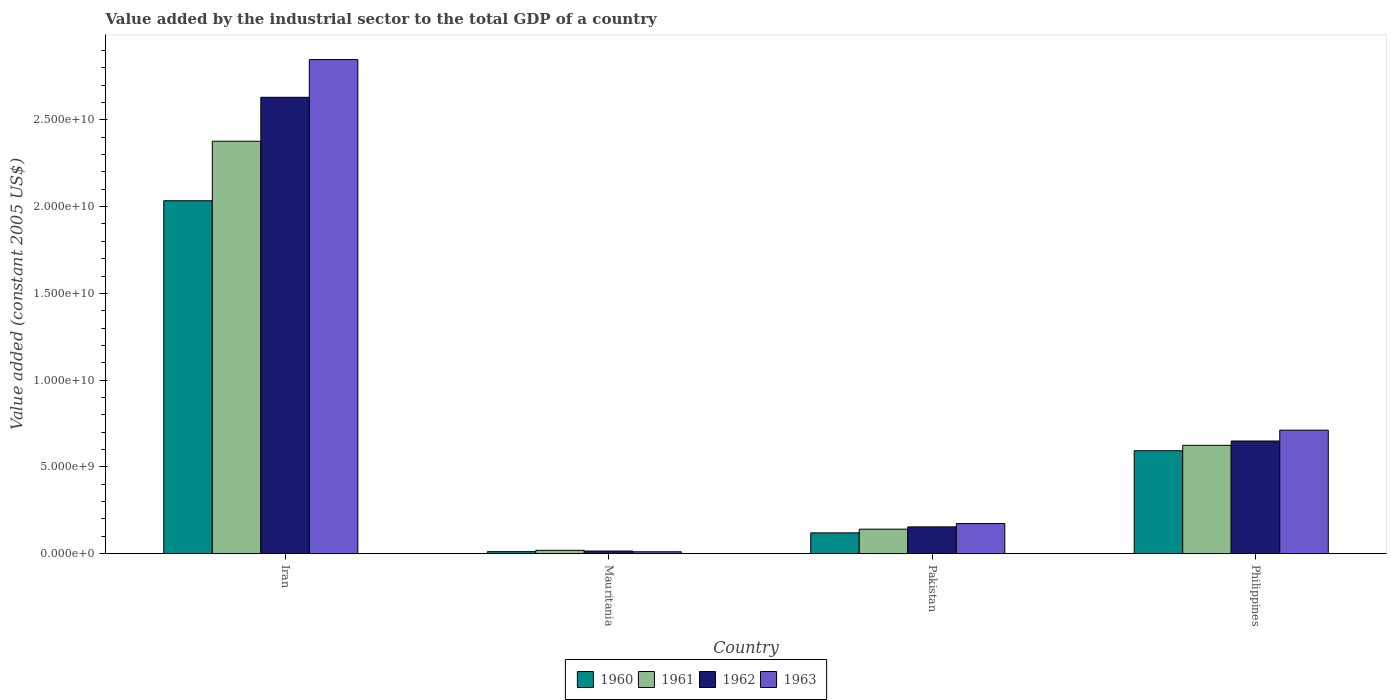How many different coloured bars are there?
Offer a very short reply. 4. Are the number of bars per tick equal to the number of legend labels?
Offer a terse response. Yes. How many bars are there on the 1st tick from the left?
Keep it short and to the point. 4. How many bars are there on the 1st tick from the right?
Make the answer very short. 4. In how many cases, is the number of bars for a given country not equal to the number of legend labels?
Offer a terse response. 0. What is the value added by the industrial sector in 1962 in Iran?
Ensure brevity in your answer.  2.63e+1. Across all countries, what is the maximum value added by the industrial sector in 1960?
Keep it short and to the point. 2.03e+1. Across all countries, what is the minimum value added by the industrial sector in 1962?
Your answer should be compact. 1.51e+08. In which country was the value added by the industrial sector in 1962 maximum?
Make the answer very short. Iran. In which country was the value added by the industrial sector in 1961 minimum?
Your answer should be compact. Mauritania. What is the total value added by the industrial sector in 1960 in the graph?
Ensure brevity in your answer.  2.76e+1. What is the difference between the value added by the industrial sector in 1960 in Mauritania and that in Philippines?
Your answer should be very brief. -5.82e+09. What is the difference between the value added by the industrial sector in 1963 in Mauritania and the value added by the industrial sector in 1960 in Philippines?
Provide a succinct answer. -5.82e+09. What is the average value added by the industrial sector in 1962 per country?
Your answer should be compact. 8.62e+09. What is the difference between the value added by the industrial sector of/in 1961 and value added by the industrial sector of/in 1962 in Pakistan?
Your answer should be compact. -1.32e+08. In how many countries, is the value added by the industrial sector in 1961 greater than 19000000000 US$?
Your answer should be compact. 1. What is the ratio of the value added by the industrial sector in 1961 in Iran to that in Philippines?
Offer a very short reply. 3.81. What is the difference between the highest and the second highest value added by the industrial sector in 1962?
Ensure brevity in your answer.  -1.98e+1. What is the difference between the highest and the lowest value added by the industrial sector in 1962?
Offer a very short reply. 2.62e+1. Is it the case that in every country, the sum of the value added by the industrial sector in 1962 and value added by the industrial sector in 1961 is greater than the sum of value added by the industrial sector in 1963 and value added by the industrial sector in 1960?
Your answer should be compact. No. How many bars are there?
Offer a very short reply. 16. How many countries are there in the graph?
Offer a very short reply. 4. What is the difference between two consecutive major ticks on the Y-axis?
Offer a terse response. 5.00e+09. Does the graph contain any zero values?
Provide a short and direct response. No. How are the legend labels stacked?
Your answer should be very brief. Horizontal. What is the title of the graph?
Offer a terse response. Value added by the industrial sector to the total GDP of a country. Does "2014" appear as one of the legend labels in the graph?
Offer a terse response. No. What is the label or title of the Y-axis?
Provide a short and direct response. Value added (constant 2005 US$). What is the Value added (constant 2005 US$) in 1960 in Iran?
Provide a succinct answer. 2.03e+1. What is the Value added (constant 2005 US$) of 1961 in Iran?
Provide a short and direct response. 2.38e+1. What is the Value added (constant 2005 US$) in 1962 in Iran?
Your response must be concise. 2.63e+1. What is the Value added (constant 2005 US$) of 1963 in Iran?
Make the answer very short. 2.85e+1. What is the Value added (constant 2005 US$) in 1960 in Mauritania?
Provide a succinct answer. 1.15e+08. What is the Value added (constant 2005 US$) of 1961 in Mauritania?
Ensure brevity in your answer.  1.92e+08. What is the Value added (constant 2005 US$) in 1962 in Mauritania?
Make the answer very short. 1.51e+08. What is the Value added (constant 2005 US$) of 1963 in Mauritania?
Your answer should be compact. 1.08e+08. What is the Value added (constant 2005 US$) in 1960 in Pakistan?
Offer a very short reply. 1.20e+09. What is the Value added (constant 2005 US$) in 1961 in Pakistan?
Your answer should be compact. 1.41e+09. What is the Value added (constant 2005 US$) in 1962 in Pakistan?
Make the answer very short. 1.54e+09. What is the Value added (constant 2005 US$) of 1963 in Pakistan?
Ensure brevity in your answer.  1.74e+09. What is the Value added (constant 2005 US$) of 1960 in Philippines?
Provide a short and direct response. 5.93e+09. What is the Value added (constant 2005 US$) of 1961 in Philippines?
Keep it short and to the point. 6.24e+09. What is the Value added (constant 2005 US$) of 1962 in Philippines?
Keep it short and to the point. 6.49e+09. What is the Value added (constant 2005 US$) of 1963 in Philippines?
Give a very brief answer. 7.12e+09. Across all countries, what is the maximum Value added (constant 2005 US$) of 1960?
Ensure brevity in your answer.  2.03e+1. Across all countries, what is the maximum Value added (constant 2005 US$) of 1961?
Your response must be concise. 2.38e+1. Across all countries, what is the maximum Value added (constant 2005 US$) of 1962?
Offer a very short reply. 2.63e+1. Across all countries, what is the maximum Value added (constant 2005 US$) in 1963?
Your answer should be compact. 2.85e+1. Across all countries, what is the minimum Value added (constant 2005 US$) in 1960?
Provide a succinct answer. 1.15e+08. Across all countries, what is the minimum Value added (constant 2005 US$) in 1961?
Give a very brief answer. 1.92e+08. Across all countries, what is the minimum Value added (constant 2005 US$) of 1962?
Make the answer very short. 1.51e+08. Across all countries, what is the minimum Value added (constant 2005 US$) of 1963?
Provide a succinct answer. 1.08e+08. What is the total Value added (constant 2005 US$) of 1960 in the graph?
Your answer should be compact. 2.76e+1. What is the total Value added (constant 2005 US$) of 1961 in the graph?
Make the answer very short. 3.16e+1. What is the total Value added (constant 2005 US$) in 1962 in the graph?
Your answer should be very brief. 3.45e+1. What is the total Value added (constant 2005 US$) of 1963 in the graph?
Provide a short and direct response. 3.74e+1. What is the difference between the Value added (constant 2005 US$) of 1960 in Iran and that in Mauritania?
Your response must be concise. 2.02e+1. What is the difference between the Value added (constant 2005 US$) in 1961 in Iran and that in Mauritania?
Offer a very short reply. 2.36e+1. What is the difference between the Value added (constant 2005 US$) of 1962 in Iran and that in Mauritania?
Offer a terse response. 2.62e+1. What is the difference between the Value added (constant 2005 US$) in 1963 in Iran and that in Mauritania?
Your answer should be very brief. 2.84e+1. What is the difference between the Value added (constant 2005 US$) of 1960 in Iran and that in Pakistan?
Offer a terse response. 1.91e+1. What is the difference between the Value added (constant 2005 US$) in 1961 in Iran and that in Pakistan?
Offer a very short reply. 2.24e+1. What is the difference between the Value added (constant 2005 US$) of 1962 in Iran and that in Pakistan?
Provide a short and direct response. 2.48e+1. What is the difference between the Value added (constant 2005 US$) in 1963 in Iran and that in Pakistan?
Make the answer very short. 2.67e+1. What is the difference between the Value added (constant 2005 US$) of 1960 in Iran and that in Philippines?
Your response must be concise. 1.44e+1. What is the difference between the Value added (constant 2005 US$) in 1961 in Iran and that in Philippines?
Make the answer very short. 1.75e+1. What is the difference between the Value added (constant 2005 US$) of 1962 in Iran and that in Philippines?
Give a very brief answer. 1.98e+1. What is the difference between the Value added (constant 2005 US$) in 1963 in Iran and that in Philippines?
Provide a short and direct response. 2.14e+1. What is the difference between the Value added (constant 2005 US$) of 1960 in Mauritania and that in Pakistan?
Ensure brevity in your answer.  -1.08e+09. What is the difference between the Value added (constant 2005 US$) of 1961 in Mauritania and that in Pakistan?
Ensure brevity in your answer.  -1.22e+09. What is the difference between the Value added (constant 2005 US$) in 1962 in Mauritania and that in Pakistan?
Your answer should be very brief. -1.39e+09. What is the difference between the Value added (constant 2005 US$) in 1963 in Mauritania and that in Pakistan?
Keep it short and to the point. -1.63e+09. What is the difference between the Value added (constant 2005 US$) of 1960 in Mauritania and that in Philippines?
Your answer should be compact. -5.82e+09. What is the difference between the Value added (constant 2005 US$) in 1961 in Mauritania and that in Philippines?
Provide a short and direct response. -6.05e+09. What is the difference between the Value added (constant 2005 US$) of 1962 in Mauritania and that in Philippines?
Offer a terse response. -6.34e+09. What is the difference between the Value added (constant 2005 US$) of 1963 in Mauritania and that in Philippines?
Offer a very short reply. -7.01e+09. What is the difference between the Value added (constant 2005 US$) in 1960 in Pakistan and that in Philippines?
Keep it short and to the point. -4.73e+09. What is the difference between the Value added (constant 2005 US$) in 1961 in Pakistan and that in Philippines?
Your response must be concise. -4.83e+09. What is the difference between the Value added (constant 2005 US$) in 1962 in Pakistan and that in Philippines?
Your response must be concise. -4.95e+09. What is the difference between the Value added (constant 2005 US$) of 1963 in Pakistan and that in Philippines?
Provide a short and direct response. -5.38e+09. What is the difference between the Value added (constant 2005 US$) in 1960 in Iran and the Value added (constant 2005 US$) in 1961 in Mauritania?
Keep it short and to the point. 2.01e+1. What is the difference between the Value added (constant 2005 US$) of 1960 in Iran and the Value added (constant 2005 US$) of 1962 in Mauritania?
Your response must be concise. 2.02e+1. What is the difference between the Value added (constant 2005 US$) in 1960 in Iran and the Value added (constant 2005 US$) in 1963 in Mauritania?
Provide a succinct answer. 2.02e+1. What is the difference between the Value added (constant 2005 US$) in 1961 in Iran and the Value added (constant 2005 US$) in 1962 in Mauritania?
Make the answer very short. 2.36e+1. What is the difference between the Value added (constant 2005 US$) of 1961 in Iran and the Value added (constant 2005 US$) of 1963 in Mauritania?
Give a very brief answer. 2.37e+1. What is the difference between the Value added (constant 2005 US$) in 1962 in Iran and the Value added (constant 2005 US$) in 1963 in Mauritania?
Make the answer very short. 2.62e+1. What is the difference between the Value added (constant 2005 US$) in 1960 in Iran and the Value added (constant 2005 US$) in 1961 in Pakistan?
Your response must be concise. 1.89e+1. What is the difference between the Value added (constant 2005 US$) of 1960 in Iran and the Value added (constant 2005 US$) of 1962 in Pakistan?
Give a very brief answer. 1.88e+1. What is the difference between the Value added (constant 2005 US$) in 1960 in Iran and the Value added (constant 2005 US$) in 1963 in Pakistan?
Provide a short and direct response. 1.86e+1. What is the difference between the Value added (constant 2005 US$) of 1961 in Iran and the Value added (constant 2005 US$) of 1962 in Pakistan?
Make the answer very short. 2.22e+1. What is the difference between the Value added (constant 2005 US$) of 1961 in Iran and the Value added (constant 2005 US$) of 1963 in Pakistan?
Your response must be concise. 2.20e+1. What is the difference between the Value added (constant 2005 US$) of 1962 in Iran and the Value added (constant 2005 US$) of 1963 in Pakistan?
Make the answer very short. 2.46e+1. What is the difference between the Value added (constant 2005 US$) of 1960 in Iran and the Value added (constant 2005 US$) of 1961 in Philippines?
Offer a terse response. 1.41e+1. What is the difference between the Value added (constant 2005 US$) of 1960 in Iran and the Value added (constant 2005 US$) of 1962 in Philippines?
Provide a short and direct response. 1.38e+1. What is the difference between the Value added (constant 2005 US$) of 1960 in Iran and the Value added (constant 2005 US$) of 1963 in Philippines?
Offer a very short reply. 1.32e+1. What is the difference between the Value added (constant 2005 US$) of 1961 in Iran and the Value added (constant 2005 US$) of 1962 in Philippines?
Your answer should be very brief. 1.73e+1. What is the difference between the Value added (constant 2005 US$) in 1961 in Iran and the Value added (constant 2005 US$) in 1963 in Philippines?
Your answer should be very brief. 1.67e+1. What is the difference between the Value added (constant 2005 US$) in 1962 in Iran and the Value added (constant 2005 US$) in 1963 in Philippines?
Provide a succinct answer. 1.92e+1. What is the difference between the Value added (constant 2005 US$) of 1960 in Mauritania and the Value added (constant 2005 US$) of 1961 in Pakistan?
Provide a short and direct response. -1.30e+09. What is the difference between the Value added (constant 2005 US$) of 1960 in Mauritania and the Value added (constant 2005 US$) of 1962 in Pakistan?
Give a very brief answer. -1.43e+09. What is the difference between the Value added (constant 2005 US$) of 1960 in Mauritania and the Value added (constant 2005 US$) of 1963 in Pakistan?
Offer a terse response. -1.62e+09. What is the difference between the Value added (constant 2005 US$) of 1961 in Mauritania and the Value added (constant 2005 US$) of 1962 in Pakistan?
Provide a succinct answer. -1.35e+09. What is the difference between the Value added (constant 2005 US$) of 1961 in Mauritania and the Value added (constant 2005 US$) of 1963 in Pakistan?
Your response must be concise. -1.54e+09. What is the difference between the Value added (constant 2005 US$) of 1962 in Mauritania and the Value added (constant 2005 US$) of 1963 in Pakistan?
Your answer should be very brief. -1.58e+09. What is the difference between the Value added (constant 2005 US$) in 1960 in Mauritania and the Value added (constant 2005 US$) in 1961 in Philippines?
Ensure brevity in your answer.  -6.13e+09. What is the difference between the Value added (constant 2005 US$) of 1960 in Mauritania and the Value added (constant 2005 US$) of 1962 in Philippines?
Ensure brevity in your answer.  -6.38e+09. What is the difference between the Value added (constant 2005 US$) of 1960 in Mauritania and the Value added (constant 2005 US$) of 1963 in Philippines?
Provide a succinct answer. -7.00e+09. What is the difference between the Value added (constant 2005 US$) in 1961 in Mauritania and the Value added (constant 2005 US$) in 1962 in Philippines?
Your answer should be compact. -6.30e+09. What is the difference between the Value added (constant 2005 US$) in 1961 in Mauritania and the Value added (constant 2005 US$) in 1963 in Philippines?
Give a very brief answer. -6.93e+09. What is the difference between the Value added (constant 2005 US$) in 1962 in Mauritania and the Value added (constant 2005 US$) in 1963 in Philippines?
Offer a very short reply. -6.97e+09. What is the difference between the Value added (constant 2005 US$) in 1960 in Pakistan and the Value added (constant 2005 US$) in 1961 in Philippines?
Your answer should be compact. -5.05e+09. What is the difference between the Value added (constant 2005 US$) in 1960 in Pakistan and the Value added (constant 2005 US$) in 1962 in Philippines?
Offer a terse response. -5.30e+09. What is the difference between the Value added (constant 2005 US$) in 1960 in Pakistan and the Value added (constant 2005 US$) in 1963 in Philippines?
Provide a succinct answer. -5.92e+09. What is the difference between the Value added (constant 2005 US$) in 1961 in Pakistan and the Value added (constant 2005 US$) in 1962 in Philippines?
Your response must be concise. -5.08e+09. What is the difference between the Value added (constant 2005 US$) in 1961 in Pakistan and the Value added (constant 2005 US$) in 1963 in Philippines?
Ensure brevity in your answer.  -5.71e+09. What is the difference between the Value added (constant 2005 US$) in 1962 in Pakistan and the Value added (constant 2005 US$) in 1963 in Philippines?
Your answer should be very brief. -5.57e+09. What is the average Value added (constant 2005 US$) of 1960 per country?
Your answer should be very brief. 6.90e+09. What is the average Value added (constant 2005 US$) of 1961 per country?
Keep it short and to the point. 7.90e+09. What is the average Value added (constant 2005 US$) of 1962 per country?
Keep it short and to the point. 8.62e+09. What is the average Value added (constant 2005 US$) of 1963 per country?
Your response must be concise. 9.36e+09. What is the difference between the Value added (constant 2005 US$) of 1960 and Value added (constant 2005 US$) of 1961 in Iran?
Make the answer very short. -3.43e+09. What is the difference between the Value added (constant 2005 US$) of 1960 and Value added (constant 2005 US$) of 1962 in Iran?
Offer a terse response. -5.96e+09. What is the difference between the Value added (constant 2005 US$) in 1960 and Value added (constant 2005 US$) in 1963 in Iran?
Provide a succinct answer. -8.14e+09. What is the difference between the Value added (constant 2005 US$) in 1961 and Value added (constant 2005 US$) in 1962 in Iran?
Your answer should be very brief. -2.53e+09. What is the difference between the Value added (constant 2005 US$) in 1961 and Value added (constant 2005 US$) in 1963 in Iran?
Give a very brief answer. -4.71e+09. What is the difference between the Value added (constant 2005 US$) of 1962 and Value added (constant 2005 US$) of 1963 in Iran?
Your answer should be compact. -2.17e+09. What is the difference between the Value added (constant 2005 US$) of 1960 and Value added (constant 2005 US$) of 1961 in Mauritania?
Offer a terse response. -7.68e+07. What is the difference between the Value added (constant 2005 US$) of 1960 and Value added (constant 2005 US$) of 1962 in Mauritania?
Your answer should be compact. -3.59e+07. What is the difference between the Value added (constant 2005 US$) of 1960 and Value added (constant 2005 US$) of 1963 in Mauritania?
Ensure brevity in your answer.  7.13e+06. What is the difference between the Value added (constant 2005 US$) in 1961 and Value added (constant 2005 US$) in 1962 in Mauritania?
Your answer should be very brief. 4.09e+07. What is the difference between the Value added (constant 2005 US$) in 1961 and Value added (constant 2005 US$) in 1963 in Mauritania?
Keep it short and to the point. 8.39e+07. What is the difference between the Value added (constant 2005 US$) in 1962 and Value added (constant 2005 US$) in 1963 in Mauritania?
Offer a very short reply. 4.31e+07. What is the difference between the Value added (constant 2005 US$) in 1960 and Value added (constant 2005 US$) in 1961 in Pakistan?
Offer a very short reply. -2.14e+08. What is the difference between the Value added (constant 2005 US$) in 1960 and Value added (constant 2005 US$) in 1962 in Pakistan?
Your answer should be very brief. -3.45e+08. What is the difference between the Value added (constant 2005 US$) in 1960 and Value added (constant 2005 US$) in 1963 in Pakistan?
Provide a succinct answer. -5.37e+08. What is the difference between the Value added (constant 2005 US$) in 1961 and Value added (constant 2005 US$) in 1962 in Pakistan?
Ensure brevity in your answer.  -1.32e+08. What is the difference between the Value added (constant 2005 US$) in 1961 and Value added (constant 2005 US$) in 1963 in Pakistan?
Provide a short and direct response. -3.23e+08. What is the difference between the Value added (constant 2005 US$) of 1962 and Value added (constant 2005 US$) of 1963 in Pakistan?
Offer a very short reply. -1.92e+08. What is the difference between the Value added (constant 2005 US$) of 1960 and Value added (constant 2005 US$) of 1961 in Philippines?
Provide a succinct answer. -3.11e+08. What is the difference between the Value added (constant 2005 US$) of 1960 and Value added (constant 2005 US$) of 1962 in Philippines?
Offer a very short reply. -5.61e+08. What is the difference between the Value added (constant 2005 US$) of 1960 and Value added (constant 2005 US$) of 1963 in Philippines?
Provide a succinct answer. -1.18e+09. What is the difference between the Value added (constant 2005 US$) of 1961 and Value added (constant 2005 US$) of 1962 in Philippines?
Ensure brevity in your answer.  -2.50e+08. What is the difference between the Value added (constant 2005 US$) of 1961 and Value added (constant 2005 US$) of 1963 in Philippines?
Your answer should be very brief. -8.74e+08. What is the difference between the Value added (constant 2005 US$) in 1962 and Value added (constant 2005 US$) in 1963 in Philippines?
Provide a succinct answer. -6.24e+08. What is the ratio of the Value added (constant 2005 US$) in 1960 in Iran to that in Mauritania?
Your response must be concise. 176.32. What is the ratio of the Value added (constant 2005 US$) of 1961 in Iran to that in Mauritania?
Your answer should be compact. 123.7. What is the ratio of the Value added (constant 2005 US$) in 1962 in Iran to that in Mauritania?
Make the answer very short. 173.84. What is the ratio of the Value added (constant 2005 US$) in 1963 in Iran to that in Mauritania?
Provide a short and direct response. 263.11. What is the ratio of the Value added (constant 2005 US$) in 1960 in Iran to that in Pakistan?
Provide a short and direct response. 16.98. What is the ratio of the Value added (constant 2005 US$) in 1961 in Iran to that in Pakistan?
Your response must be concise. 16.84. What is the ratio of the Value added (constant 2005 US$) of 1962 in Iran to that in Pakistan?
Give a very brief answer. 17.04. What is the ratio of the Value added (constant 2005 US$) of 1963 in Iran to that in Pakistan?
Offer a terse response. 16.41. What is the ratio of the Value added (constant 2005 US$) of 1960 in Iran to that in Philippines?
Your answer should be compact. 3.43. What is the ratio of the Value added (constant 2005 US$) of 1961 in Iran to that in Philippines?
Provide a succinct answer. 3.81. What is the ratio of the Value added (constant 2005 US$) in 1962 in Iran to that in Philippines?
Offer a terse response. 4.05. What is the ratio of the Value added (constant 2005 US$) in 1963 in Iran to that in Philippines?
Provide a short and direct response. 4. What is the ratio of the Value added (constant 2005 US$) of 1960 in Mauritania to that in Pakistan?
Keep it short and to the point. 0.1. What is the ratio of the Value added (constant 2005 US$) of 1961 in Mauritania to that in Pakistan?
Keep it short and to the point. 0.14. What is the ratio of the Value added (constant 2005 US$) of 1962 in Mauritania to that in Pakistan?
Give a very brief answer. 0.1. What is the ratio of the Value added (constant 2005 US$) in 1963 in Mauritania to that in Pakistan?
Give a very brief answer. 0.06. What is the ratio of the Value added (constant 2005 US$) of 1960 in Mauritania to that in Philippines?
Your answer should be compact. 0.02. What is the ratio of the Value added (constant 2005 US$) of 1961 in Mauritania to that in Philippines?
Your response must be concise. 0.03. What is the ratio of the Value added (constant 2005 US$) of 1962 in Mauritania to that in Philippines?
Give a very brief answer. 0.02. What is the ratio of the Value added (constant 2005 US$) of 1963 in Mauritania to that in Philippines?
Offer a terse response. 0.02. What is the ratio of the Value added (constant 2005 US$) of 1960 in Pakistan to that in Philippines?
Keep it short and to the point. 0.2. What is the ratio of the Value added (constant 2005 US$) of 1961 in Pakistan to that in Philippines?
Provide a short and direct response. 0.23. What is the ratio of the Value added (constant 2005 US$) of 1962 in Pakistan to that in Philippines?
Your response must be concise. 0.24. What is the ratio of the Value added (constant 2005 US$) in 1963 in Pakistan to that in Philippines?
Give a very brief answer. 0.24. What is the difference between the highest and the second highest Value added (constant 2005 US$) in 1960?
Your answer should be compact. 1.44e+1. What is the difference between the highest and the second highest Value added (constant 2005 US$) of 1961?
Your answer should be very brief. 1.75e+1. What is the difference between the highest and the second highest Value added (constant 2005 US$) in 1962?
Provide a succinct answer. 1.98e+1. What is the difference between the highest and the second highest Value added (constant 2005 US$) in 1963?
Give a very brief answer. 2.14e+1. What is the difference between the highest and the lowest Value added (constant 2005 US$) in 1960?
Offer a terse response. 2.02e+1. What is the difference between the highest and the lowest Value added (constant 2005 US$) of 1961?
Give a very brief answer. 2.36e+1. What is the difference between the highest and the lowest Value added (constant 2005 US$) in 1962?
Your answer should be very brief. 2.62e+1. What is the difference between the highest and the lowest Value added (constant 2005 US$) of 1963?
Offer a very short reply. 2.84e+1. 